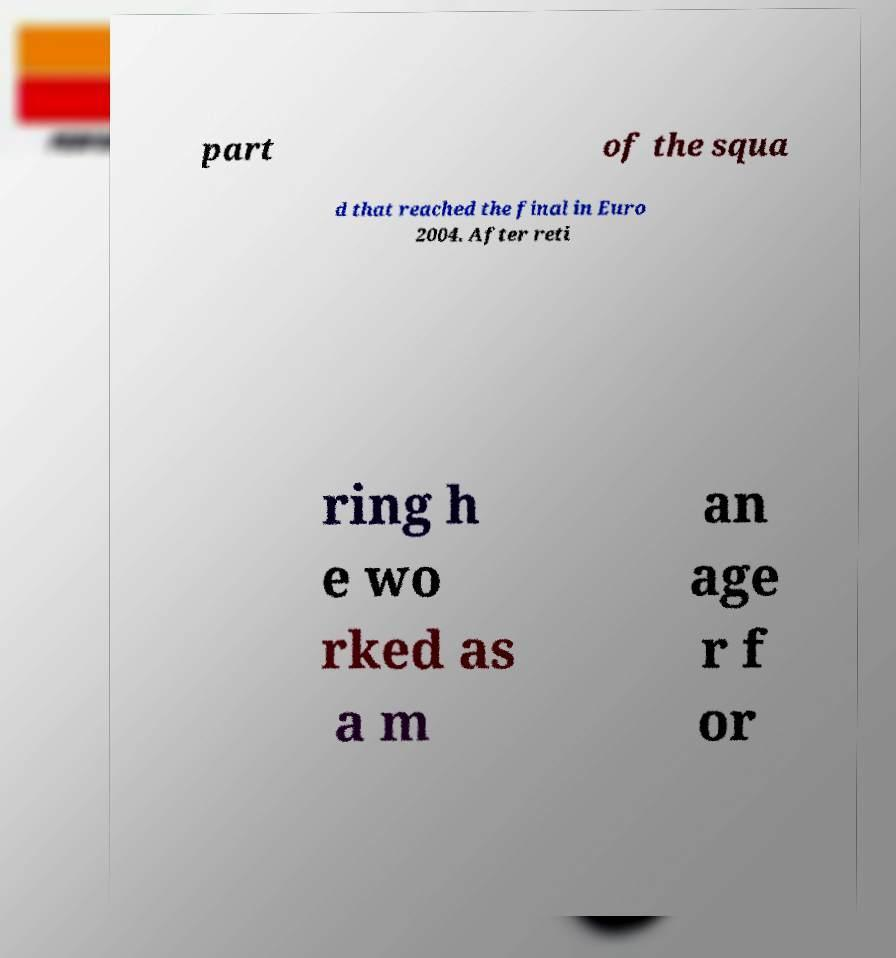Could you assist in decoding the text presented in this image and type it out clearly? part of the squa d that reached the final in Euro 2004. After reti ring h e wo rked as a m an age r f or 